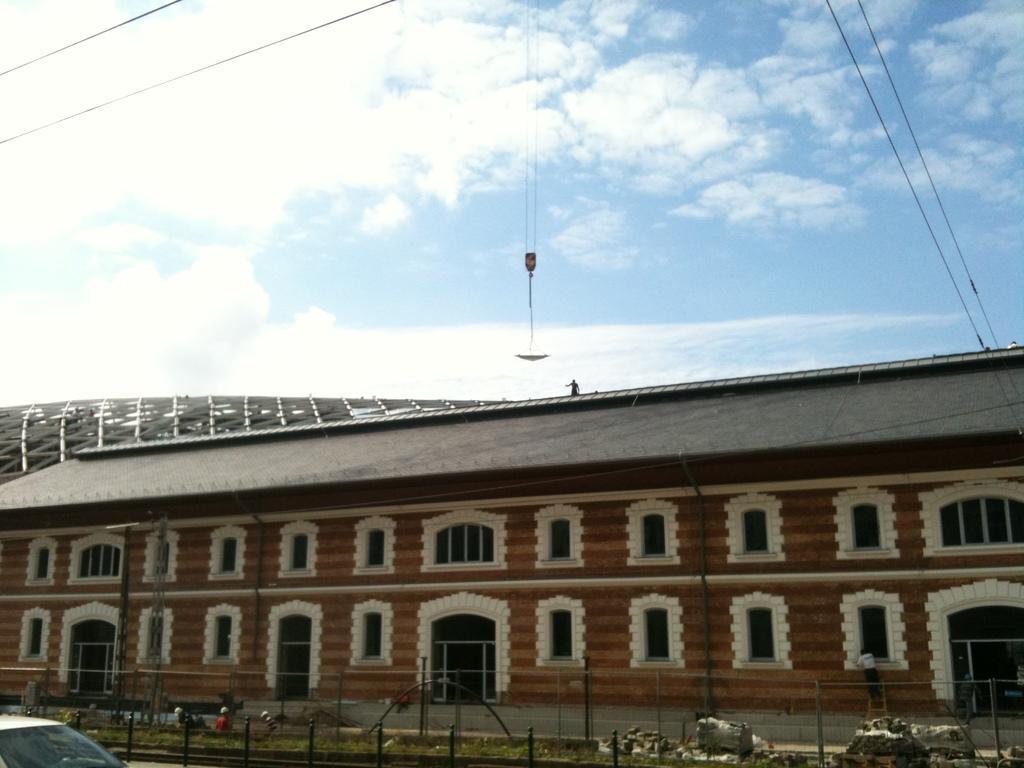Can you describe this image briefly? In this image we can see one house which looks like a palace, few objects attached to the house, some poles, on fence, some objects on the ground, few people are standing, some grass on the ground, some wires, two objects on the top of the house, one car on the bottom left side corner of the image, one object with wires in the middle of the image and at the top there is the cloudy sky. 